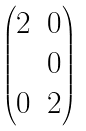Convert formula to latex. <formula><loc_0><loc_0><loc_500><loc_500>\begin{pmatrix} 2 & 0 \\ & 0 \\ 0 & 2 \end{pmatrix}</formula> 